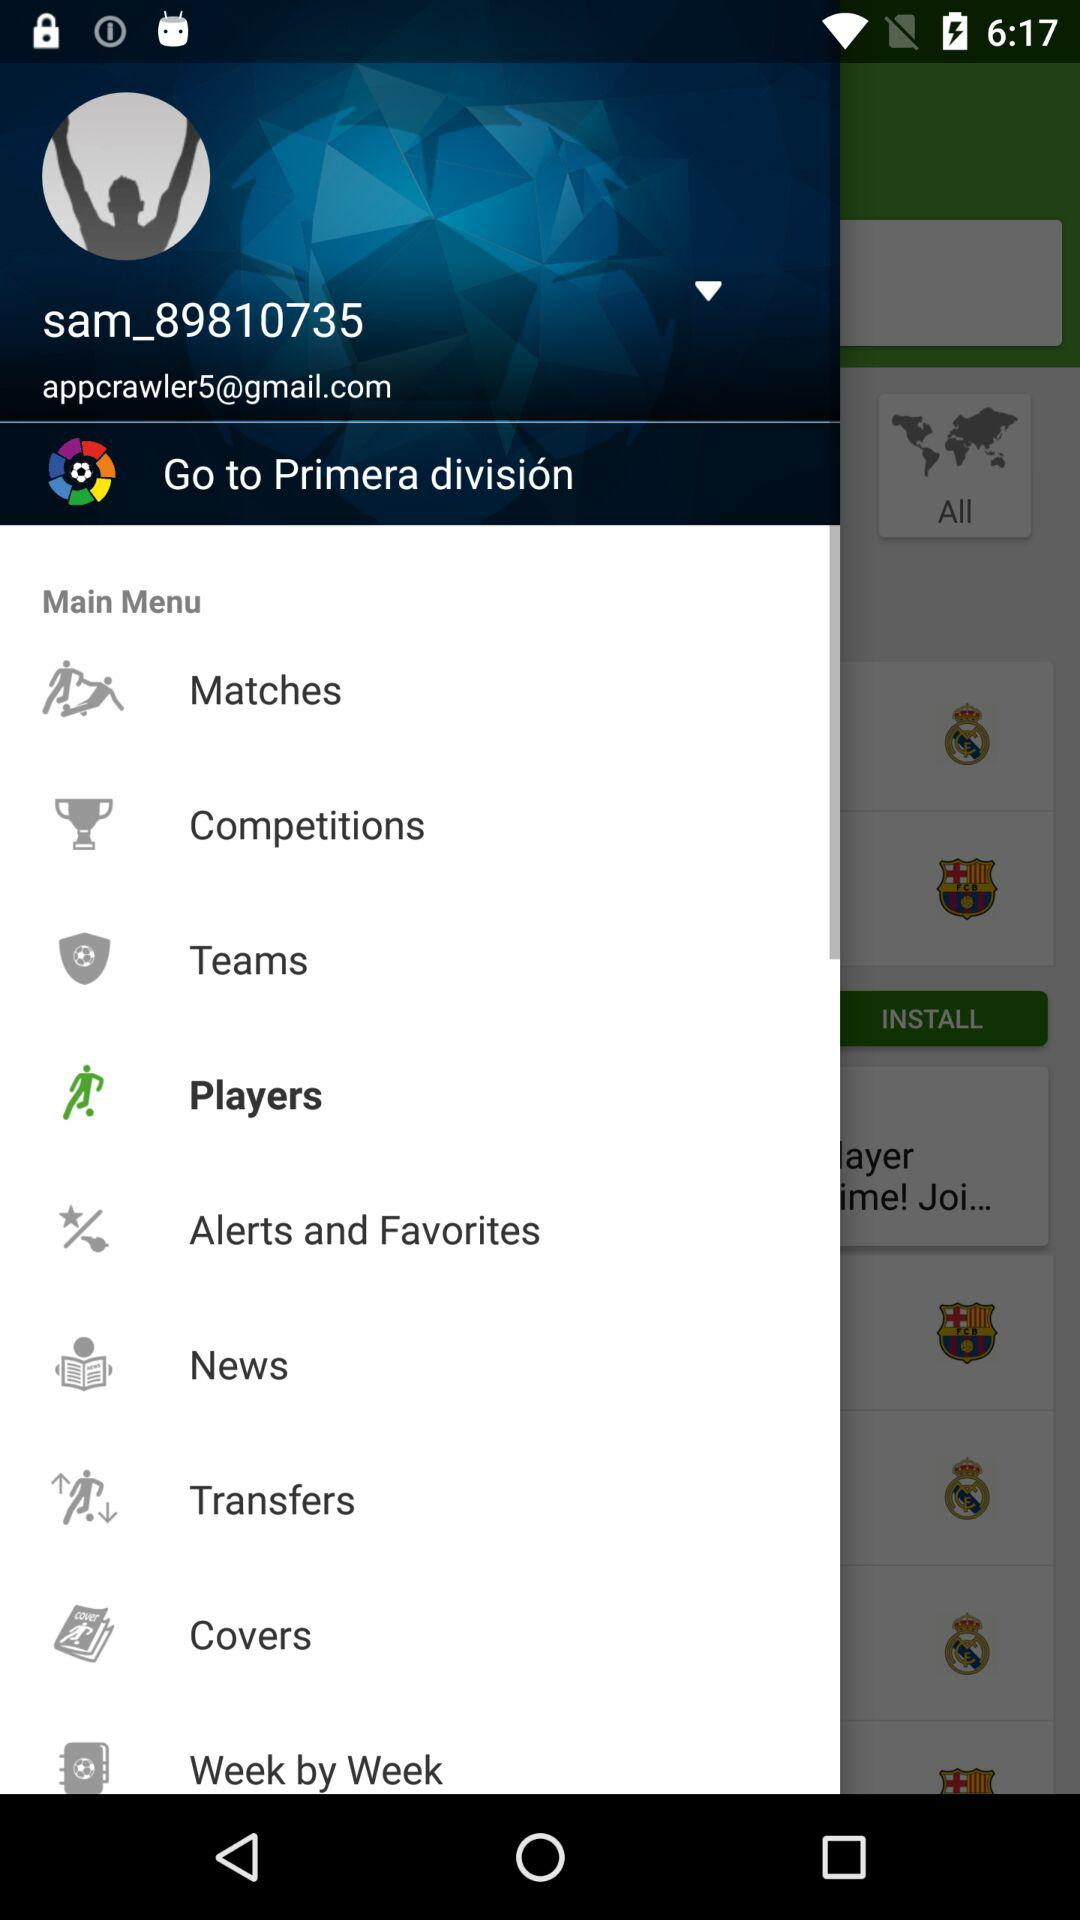What is the username shown on the app? The username shown on the app is "sam_89810735". 